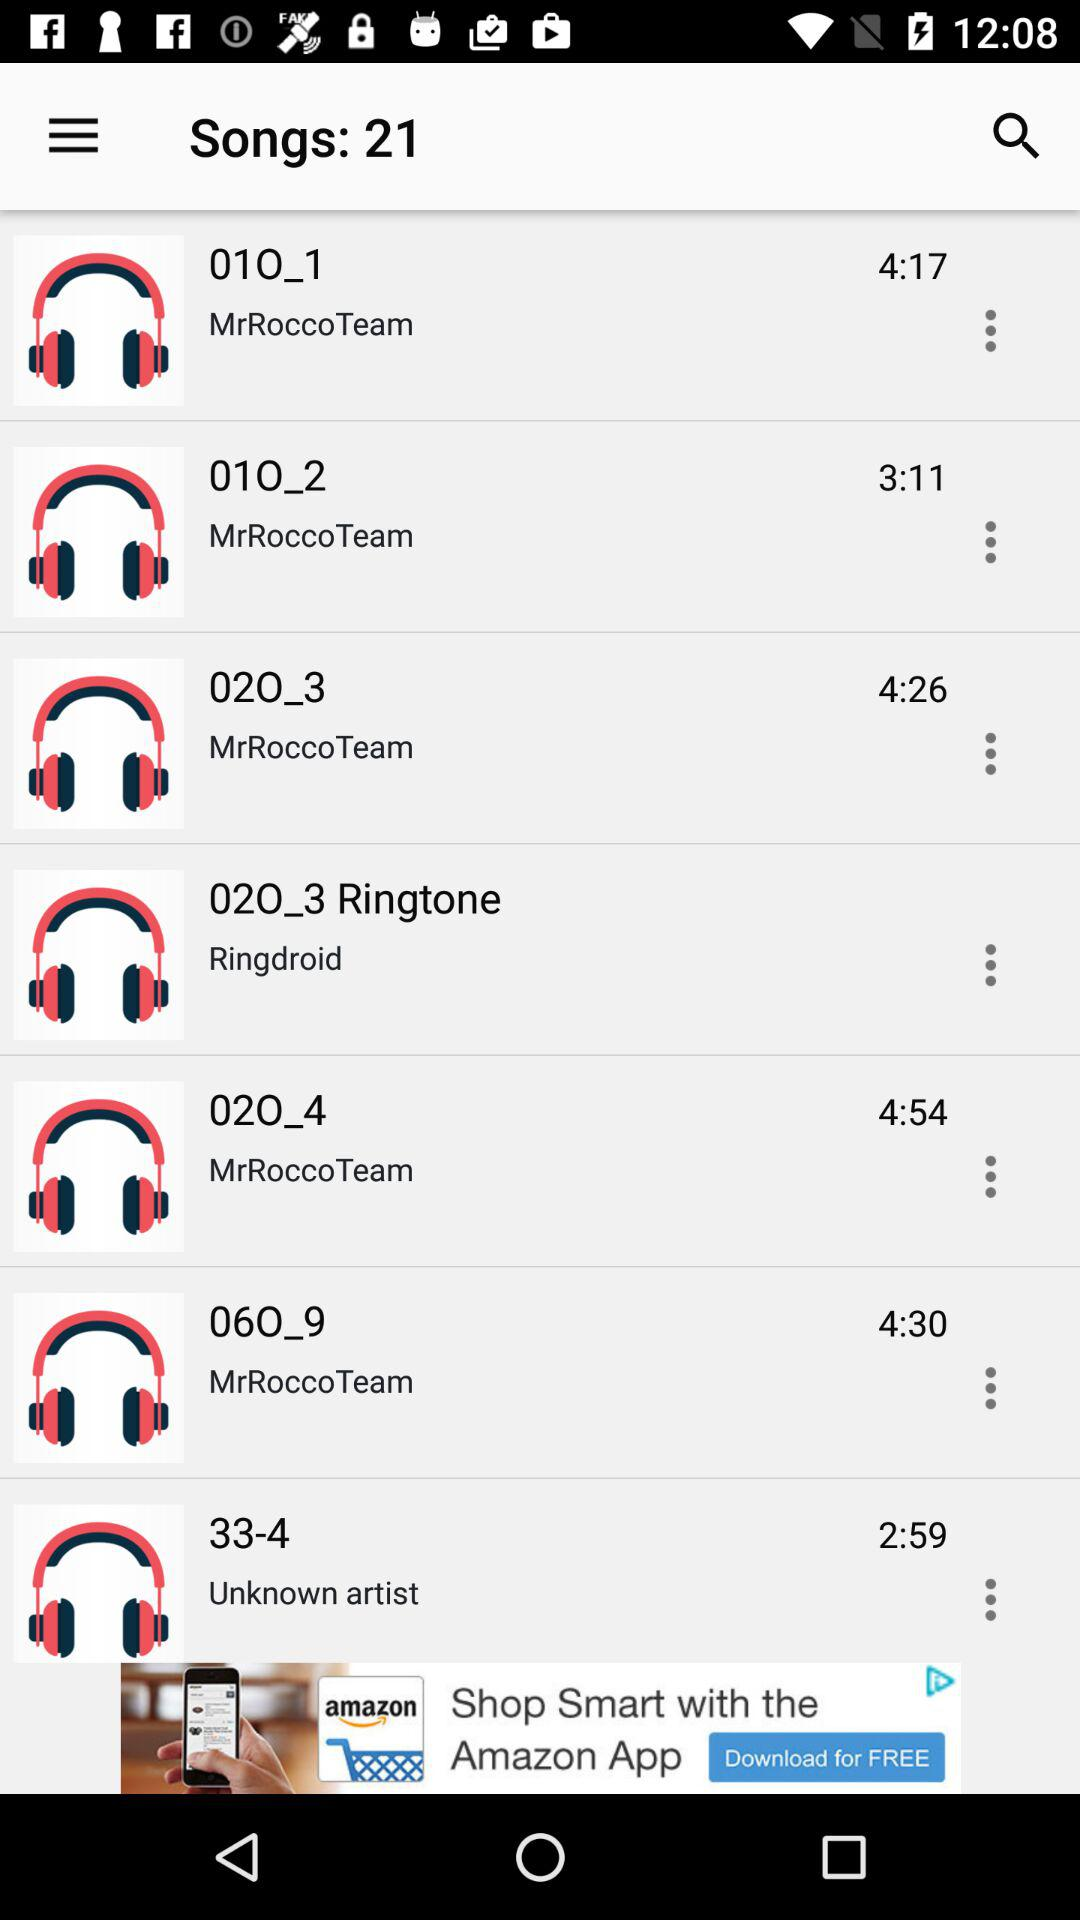What is the duration of "02O_4"? The duration of "02O_4" is 4 minutes and 54 seconds. 